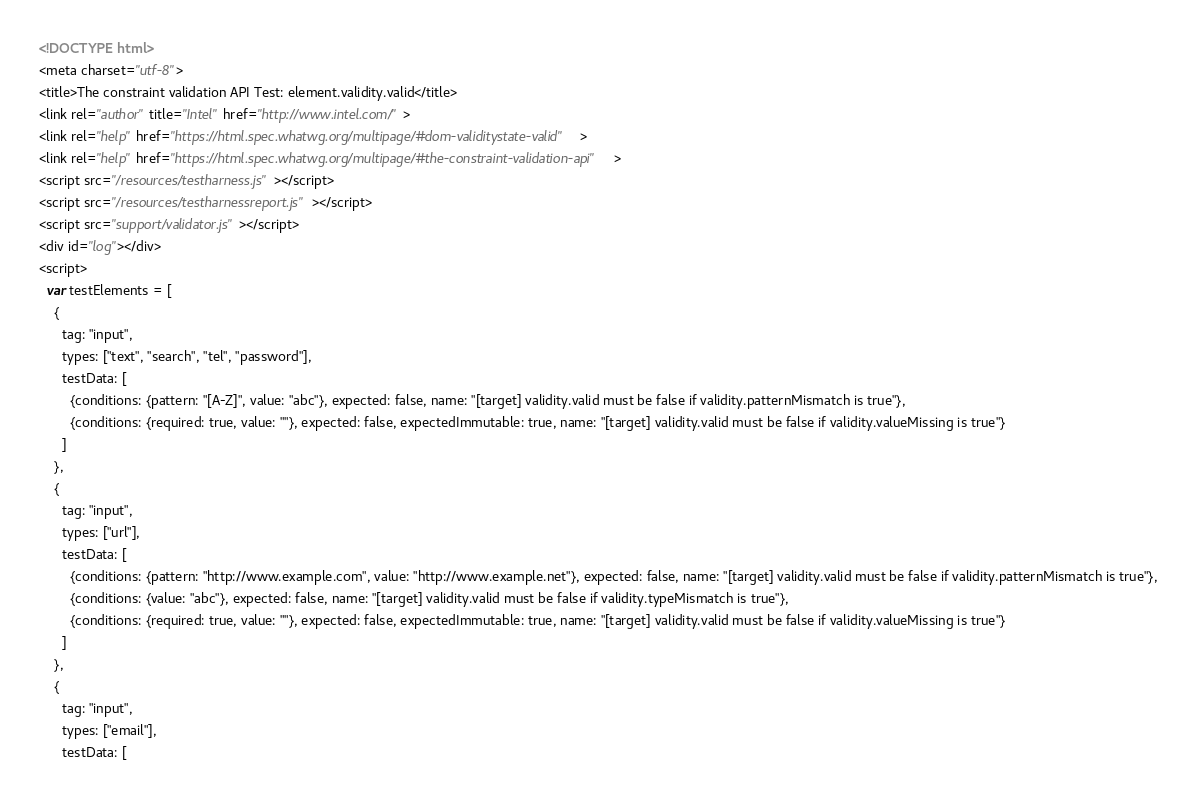<code> <loc_0><loc_0><loc_500><loc_500><_HTML_><!DOCTYPE html>
<meta charset="utf-8">
<title>The constraint validation API Test: element.validity.valid</title>
<link rel="author" title="Intel" href="http://www.intel.com/">
<link rel="help" href="https://html.spec.whatwg.org/multipage/#dom-validitystate-valid">
<link rel="help" href="https://html.spec.whatwg.org/multipage/#the-constraint-validation-api">
<script src="/resources/testharness.js"></script>
<script src="/resources/testharnessreport.js"></script>
<script src="support/validator.js"></script>
<div id="log"></div>
<script>
  var testElements = [
    {
      tag: "input",
      types: ["text", "search", "tel", "password"],
      testData: [
        {conditions: {pattern: "[A-Z]", value: "abc"}, expected: false, name: "[target] validity.valid must be false if validity.patternMismatch is true"},
        {conditions: {required: true, value: ""}, expected: false, expectedImmutable: true, name: "[target] validity.valid must be false if validity.valueMissing is true"}
      ]
    },
    {
      tag: "input",
      types: ["url"],
      testData: [
        {conditions: {pattern: "http://www.example.com", value: "http://www.example.net"}, expected: false, name: "[target] validity.valid must be false if validity.patternMismatch is true"},
        {conditions: {value: "abc"}, expected: false, name: "[target] validity.valid must be false if validity.typeMismatch is true"},
        {conditions: {required: true, value: ""}, expected: false, expectedImmutable: true, name: "[target] validity.valid must be false if validity.valueMissing is true"}
      ]
    },
    {
      tag: "input",
      types: ["email"],
      testData: [</code> 